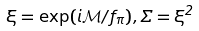Convert formula to latex. <formula><loc_0><loc_0><loc_500><loc_500>\xi = \exp ( i \mathcal { M } / f _ { \pi } ) , \Sigma = \xi ^ { 2 }</formula> 